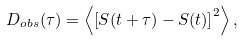Convert formula to latex. <formula><loc_0><loc_0><loc_500><loc_500>D _ { o b s } ( \tau ) = \left < \left [ S ( t + \tau ) - S ( t ) \right ] ^ { 2 } \right > ,</formula> 